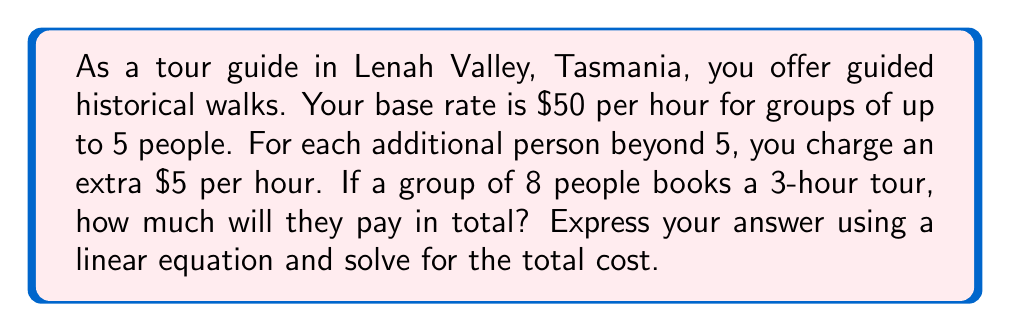What is the answer to this math problem? Let's approach this step-by-step:

1) First, let's define our variables:
   $x$ = number of additional people beyond 5
   $y$ = total cost of the tour

2) We can express this as a linear equation:
   $y = (50 + 5x) * 3$

   Where:
   - 50 is the base rate per hour
   - 5x is the additional cost per hour for extra people
   - 3 is the number of hours for the tour

3) Now, let's substitute the known values:
   - The group has 8 people, which is 3 more than the base of 5
   - So, $x = 3$

4) Let's solve the equation:
   $y = (50 + 5(3)) * 3$
   $y = (50 + 15) * 3$
   $y = 65 * 3$
   $y = 195$

Therefore, the total cost for the 3-hour tour with 8 people is $195.
Answer: $y = 195$
The total cost for the 3-hour guided historical walk in Lenah Valley for a group of 8 people is $195. 